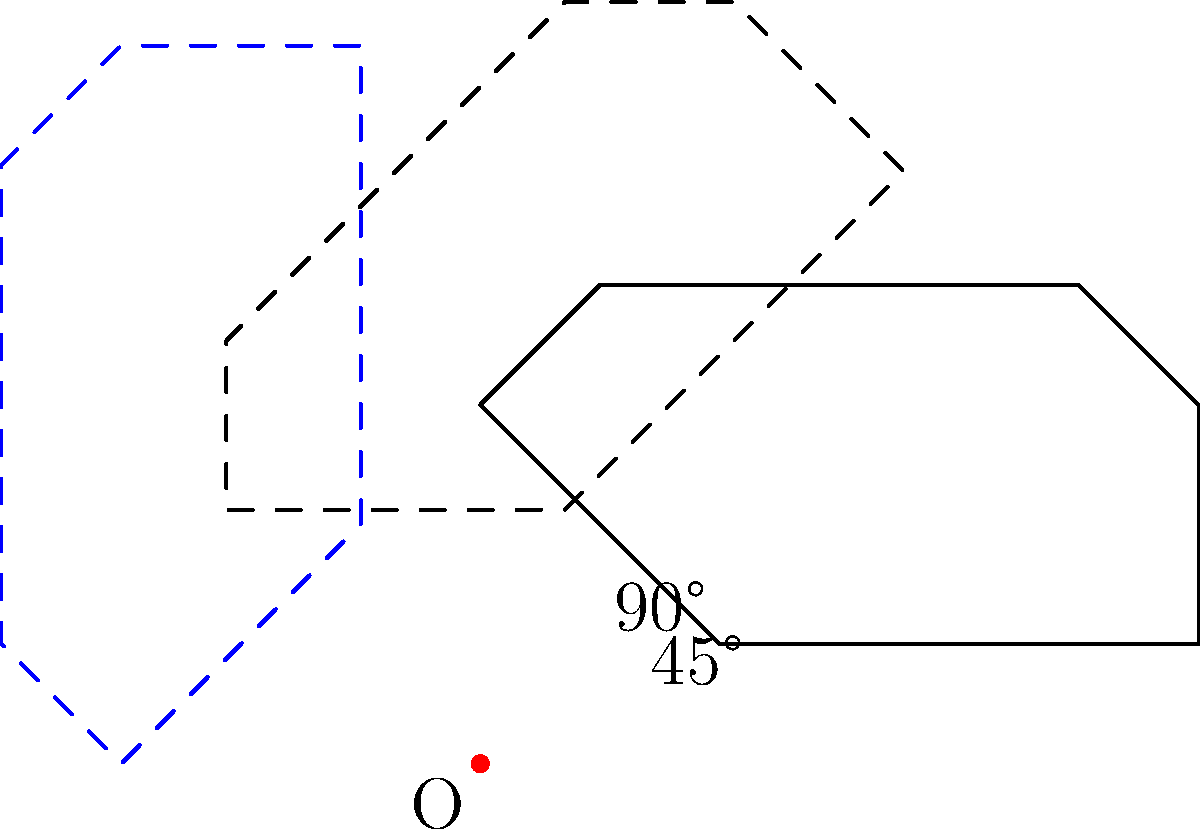A simplified silhouette of a vintage train is rotated around point O. If the train is rotated by 45°, and then by an additional 45°, what is the total angle of rotation from its original position? Let's approach this step-by-step:

1. The question presents a train silhouette that is rotated around a fixed point O.

2. The first rotation is by 45°. This is shown by the dashed outline in the diagram.

3. Then, there's an additional rotation of 45°. This is represented by the blue dashed outline in the diagram.

4. To find the total angle of rotation, we need to add these two rotations together:

   $$45° + 45° = 90°$$

5. This can be verified in the diagram, where we see the final position of the train (blue dashed outline) is at a 90° angle from the original position.

6. In rotational geometry, angles are additive when performed around the same center of rotation.

Therefore, the total angle of rotation from the train's original position is 90°.
Answer: 90° 